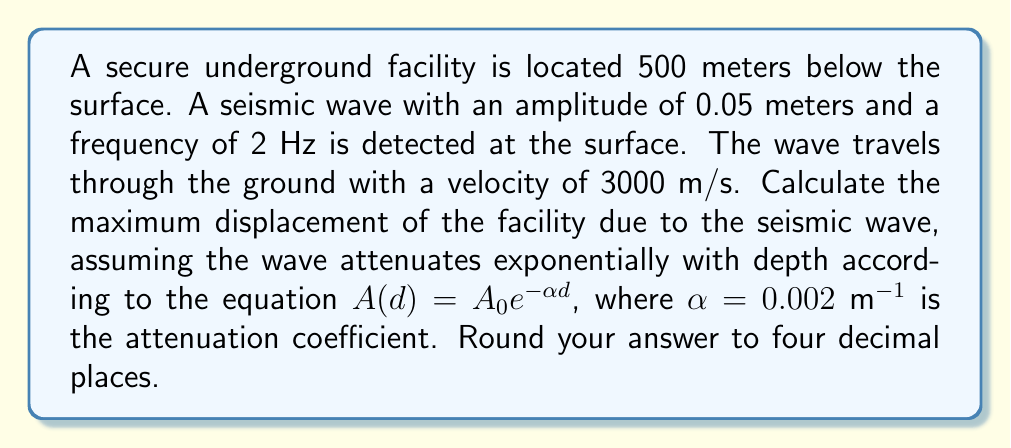Can you answer this question? To solve this problem, we'll follow these steps:

1) The displacement of a wave at depth $d$ is given by:

   $A(d) = A_0 e^{-\alpha d}$

   Where:
   $A_0$ is the initial amplitude (0.05 m)
   $\alpha$ is the attenuation coefficient (0.002 m^(-1))
   $d$ is the depth (500 m)

2) Substituting the values:

   $A(500) = 0.05 e^{-0.002 * 500}$

3) Calculate the exponent:
   
   $-0.002 * 500 = -1$

4) So our equation becomes:

   $A(500) = 0.05 e^{-1}$

5) Calculate $e^{-1}$:
   
   $e^{-1} \approx 0.3679$

6) Multiply:

   $A(500) = 0.05 * 0.3679 = 0.018395$

7) Round to four decimal places:

   $A(500) \approx 0.0184$ meters

This is the maximum displacement of the facility due to the seismic wave.
Answer: 0.0184 m 